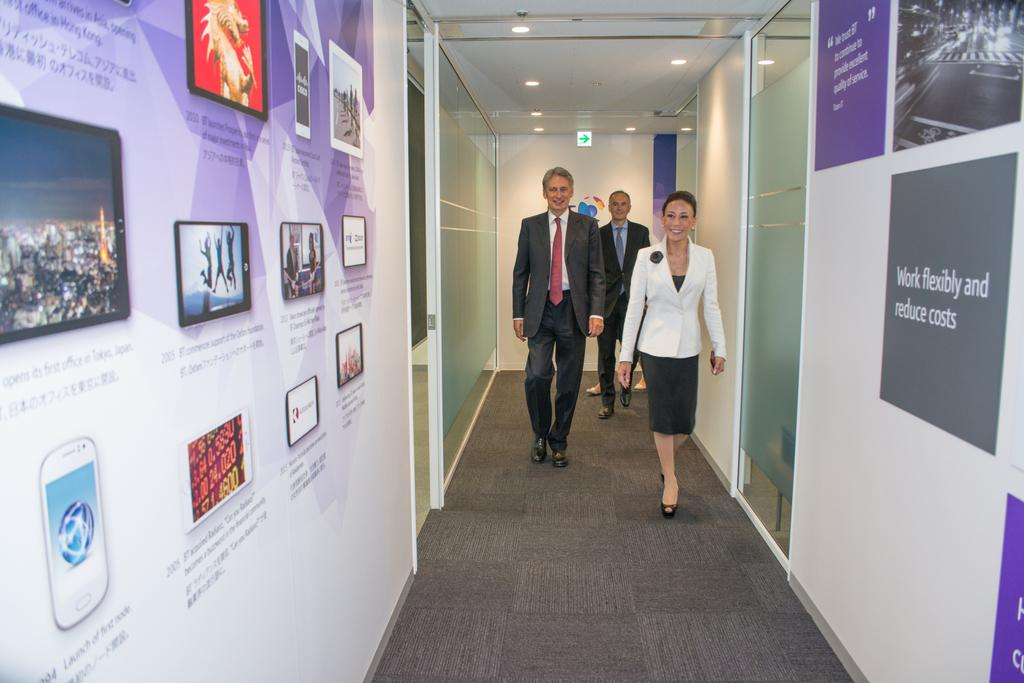<image>
Create a compact narrative representing the image presented. Three business people walk down a hallway that features signs about working flexibly and a timeline of achievements. 